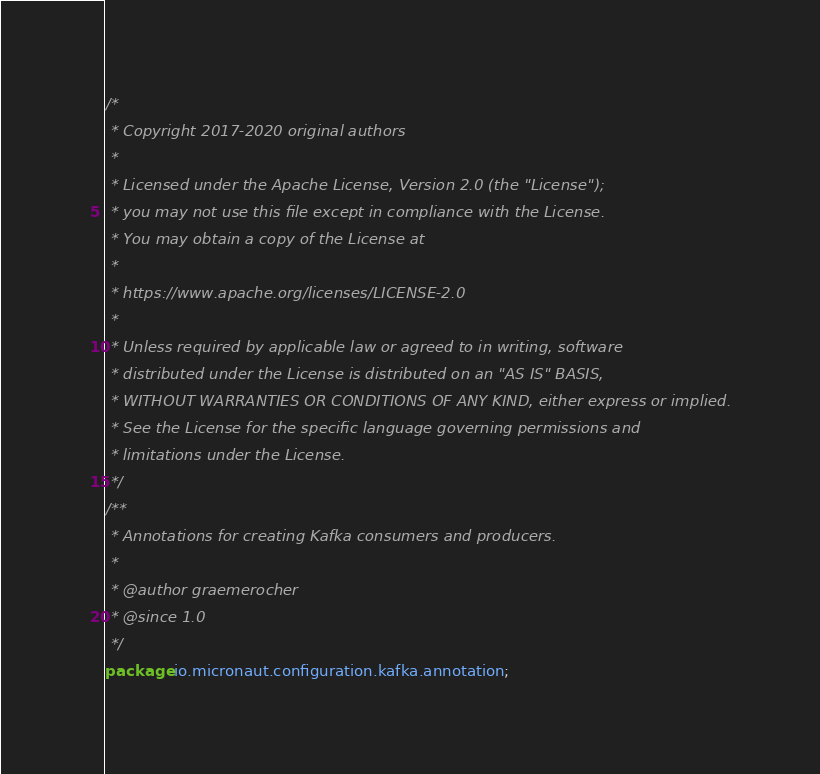<code> <loc_0><loc_0><loc_500><loc_500><_Java_>/*
 * Copyright 2017-2020 original authors
 *
 * Licensed under the Apache License, Version 2.0 (the "License");
 * you may not use this file except in compliance with the License.
 * You may obtain a copy of the License at
 *
 * https://www.apache.org/licenses/LICENSE-2.0
 *
 * Unless required by applicable law or agreed to in writing, software
 * distributed under the License is distributed on an "AS IS" BASIS,
 * WITHOUT WARRANTIES OR CONDITIONS OF ANY KIND, either express or implied.
 * See the License for the specific language governing permissions and
 * limitations under the License.
 */
/**
 * Annotations for creating Kafka consumers and producers.
 *
 * @author graemerocher
 * @since 1.0
 */
package io.micronaut.configuration.kafka.annotation;
</code> 